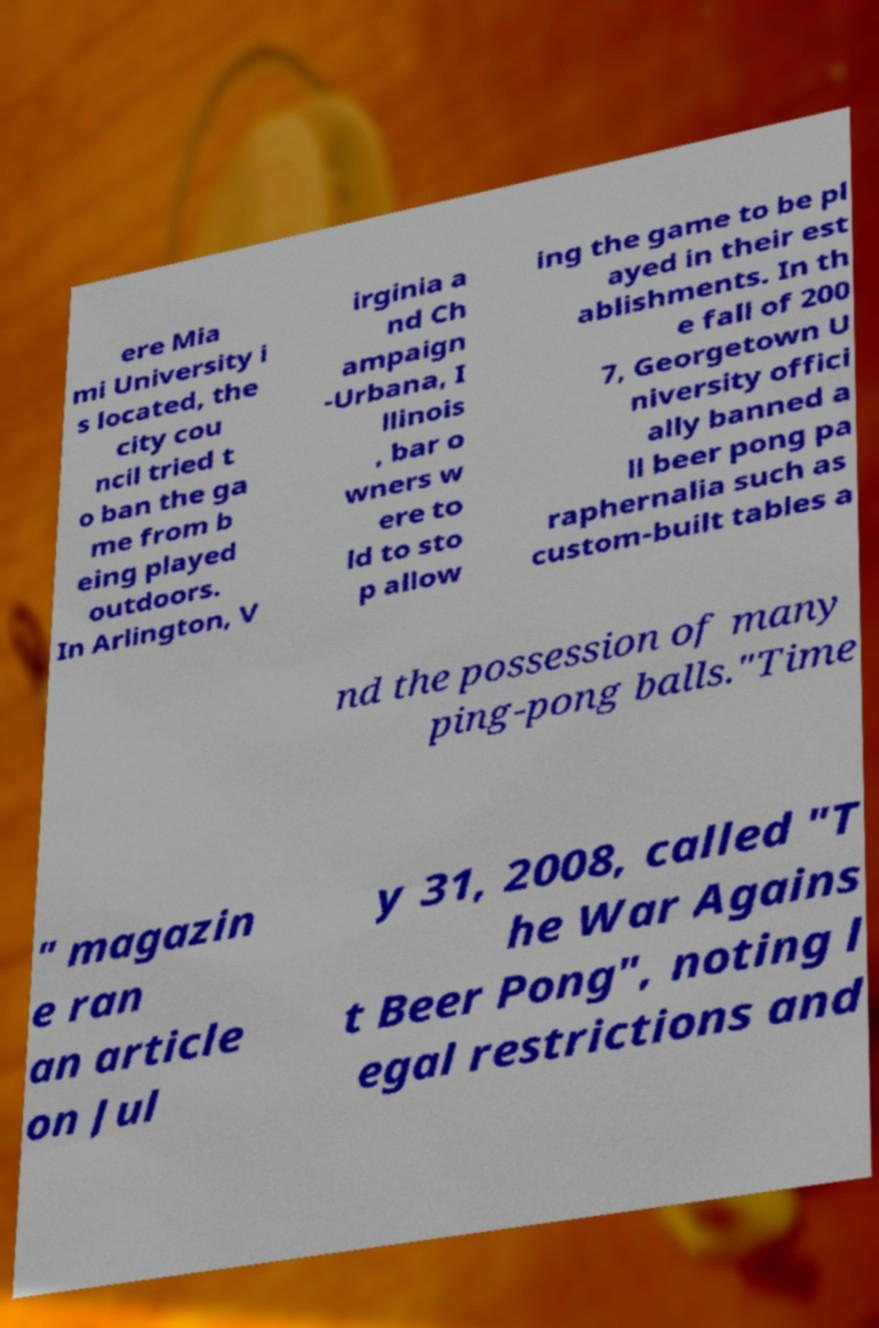For documentation purposes, I need the text within this image transcribed. Could you provide that? ere Mia mi University i s located, the city cou ncil tried t o ban the ga me from b eing played outdoors. In Arlington, V irginia a nd Ch ampaign -Urbana, I llinois , bar o wners w ere to ld to sto p allow ing the game to be pl ayed in their est ablishments. In th e fall of 200 7, Georgetown U niversity offici ally banned a ll beer pong pa raphernalia such as custom-built tables a nd the possession of many ping-pong balls."Time " magazin e ran an article on Jul y 31, 2008, called "T he War Agains t Beer Pong", noting l egal restrictions and 